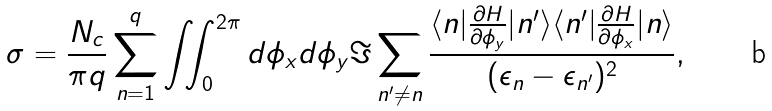Convert formula to latex. <formula><loc_0><loc_0><loc_500><loc_500>\sigma = \frac { N _ { c } } { \pi q } \sum _ { n = 1 } ^ { q } \iint _ { 0 } ^ { 2 \pi } d \phi _ { x } d \phi _ { y } \Im \sum _ { n ^ { \prime } \not = n } \frac { \langle n | \frac { \partial { H } } { \partial \phi _ { y } } | n ^ { \prime } \rangle \langle n ^ { \prime } | \frac { \partial { H } } { \partial \phi _ { x } } | n \rangle } { ( \epsilon _ { n } - \epsilon _ { n ^ { \prime } } ) ^ { 2 } } ,</formula> 